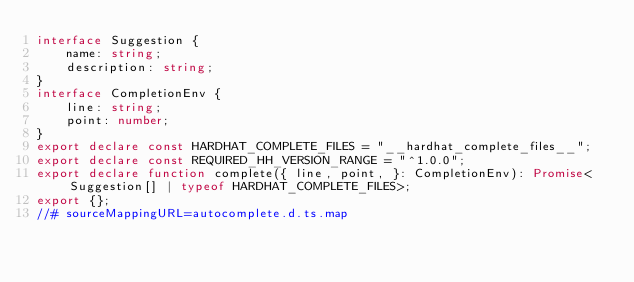Convert code to text. <code><loc_0><loc_0><loc_500><loc_500><_TypeScript_>interface Suggestion {
    name: string;
    description: string;
}
interface CompletionEnv {
    line: string;
    point: number;
}
export declare const HARDHAT_COMPLETE_FILES = "__hardhat_complete_files__";
export declare const REQUIRED_HH_VERSION_RANGE = "^1.0.0";
export declare function complete({ line, point, }: CompletionEnv): Promise<Suggestion[] | typeof HARDHAT_COMPLETE_FILES>;
export {};
//# sourceMappingURL=autocomplete.d.ts.map</code> 